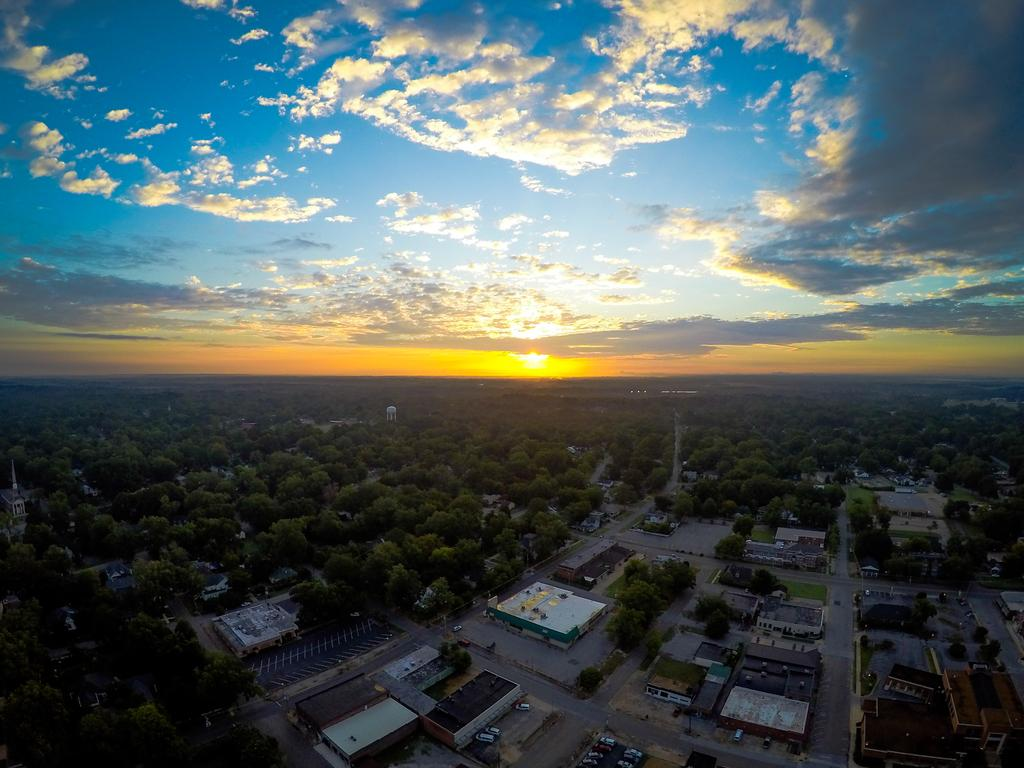What type of structures can be seen in the image? There are buildings in the image. What else is present in the image besides buildings? There are vehicles in the image. What can be seen in the background of the image? There are trees in the background of the image. What is visible at the top of the image? The sky is visible in the image, and clouds are present in the sky. Can you tell me how many experts are smiling in the image? There are no experts or smiles present in the image; it features buildings, vehicles, trees, and a sky with clouds. How many drops of water can be seen falling from the clouds in the image? There are no drops of water visible in the image; it only shows buildings, vehicles, trees, and clouds in the sky. 